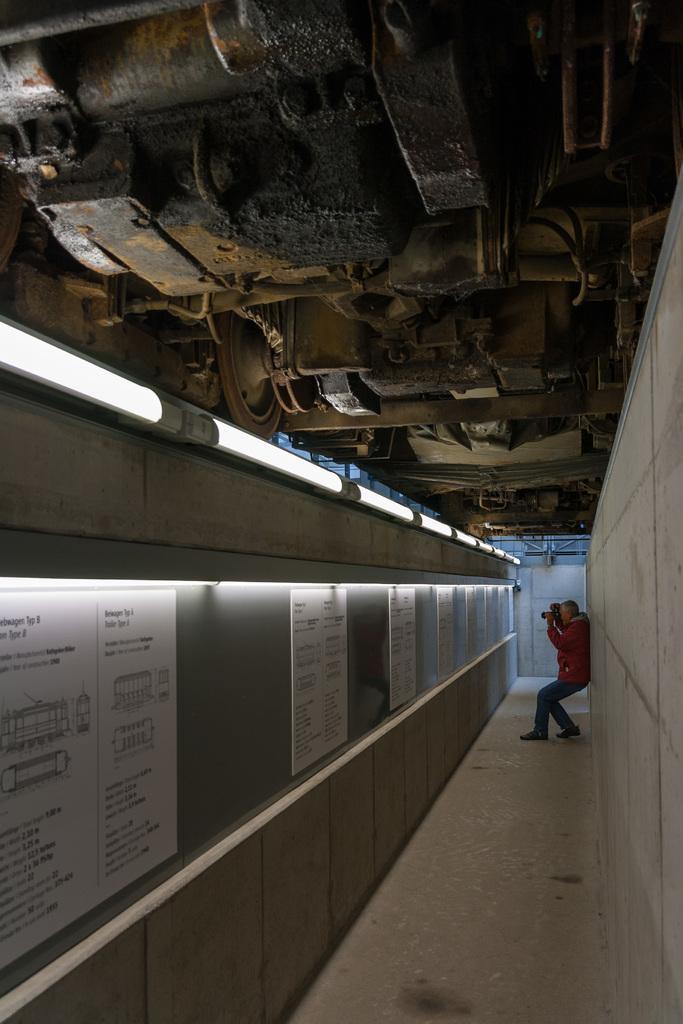Can you describe this image briefly? In this image there is a person standing and holding a camera, in front of him there are a few boards with some text are attached to the wall, above them there are few lights. At the top of the image there are like some machines. In the background there is a wall on the right side of the image there is a wall. 